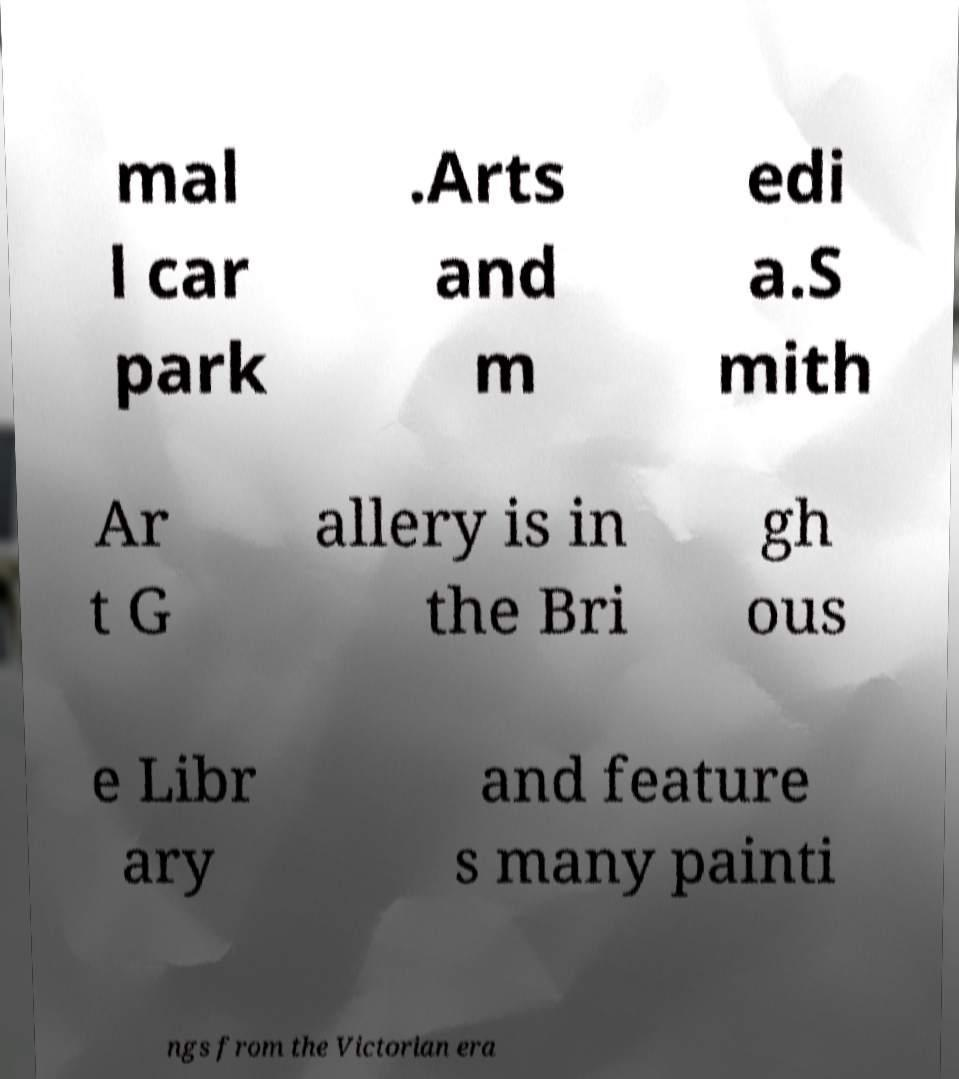Can you accurately transcribe the text from the provided image for me? mal l car park .Arts and m edi a.S mith Ar t G allery is in the Bri gh ous e Libr ary and feature s many painti ngs from the Victorian era 